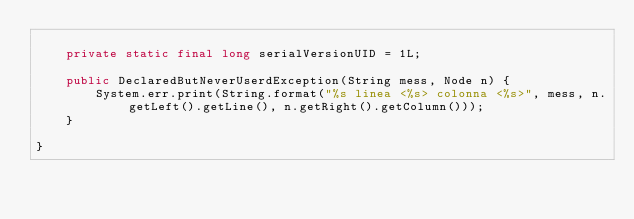Convert code to text. <code><loc_0><loc_0><loc_500><loc_500><_Java_>
	private static final long serialVersionUID = 1L;
	
	public DeclaredButNeverUserdException(String mess, Node n) {
		System.err.print(String.format("%s linea <%s> colonna <%s>", mess, n.getLeft().getLine(), n.getRight().getColumn()));
	}

}
</code> 